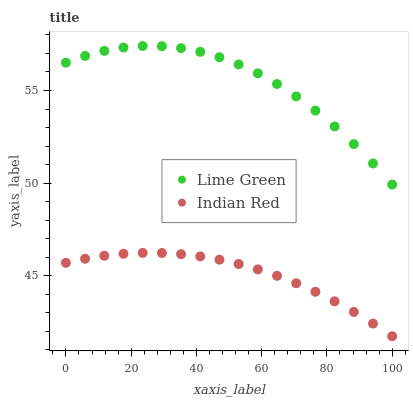Does Indian Red have the minimum area under the curve?
Answer yes or no. Yes. Does Lime Green have the maximum area under the curve?
Answer yes or no. Yes. Does Indian Red have the maximum area under the curve?
Answer yes or no. No. Is Indian Red the smoothest?
Answer yes or no. Yes. Is Lime Green the roughest?
Answer yes or no. Yes. Is Indian Red the roughest?
Answer yes or no. No. Does Indian Red have the lowest value?
Answer yes or no. Yes. Does Lime Green have the highest value?
Answer yes or no. Yes. Does Indian Red have the highest value?
Answer yes or no. No. Is Indian Red less than Lime Green?
Answer yes or no. Yes. Is Lime Green greater than Indian Red?
Answer yes or no. Yes. Does Indian Red intersect Lime Green?
Answer yes or no. No. 